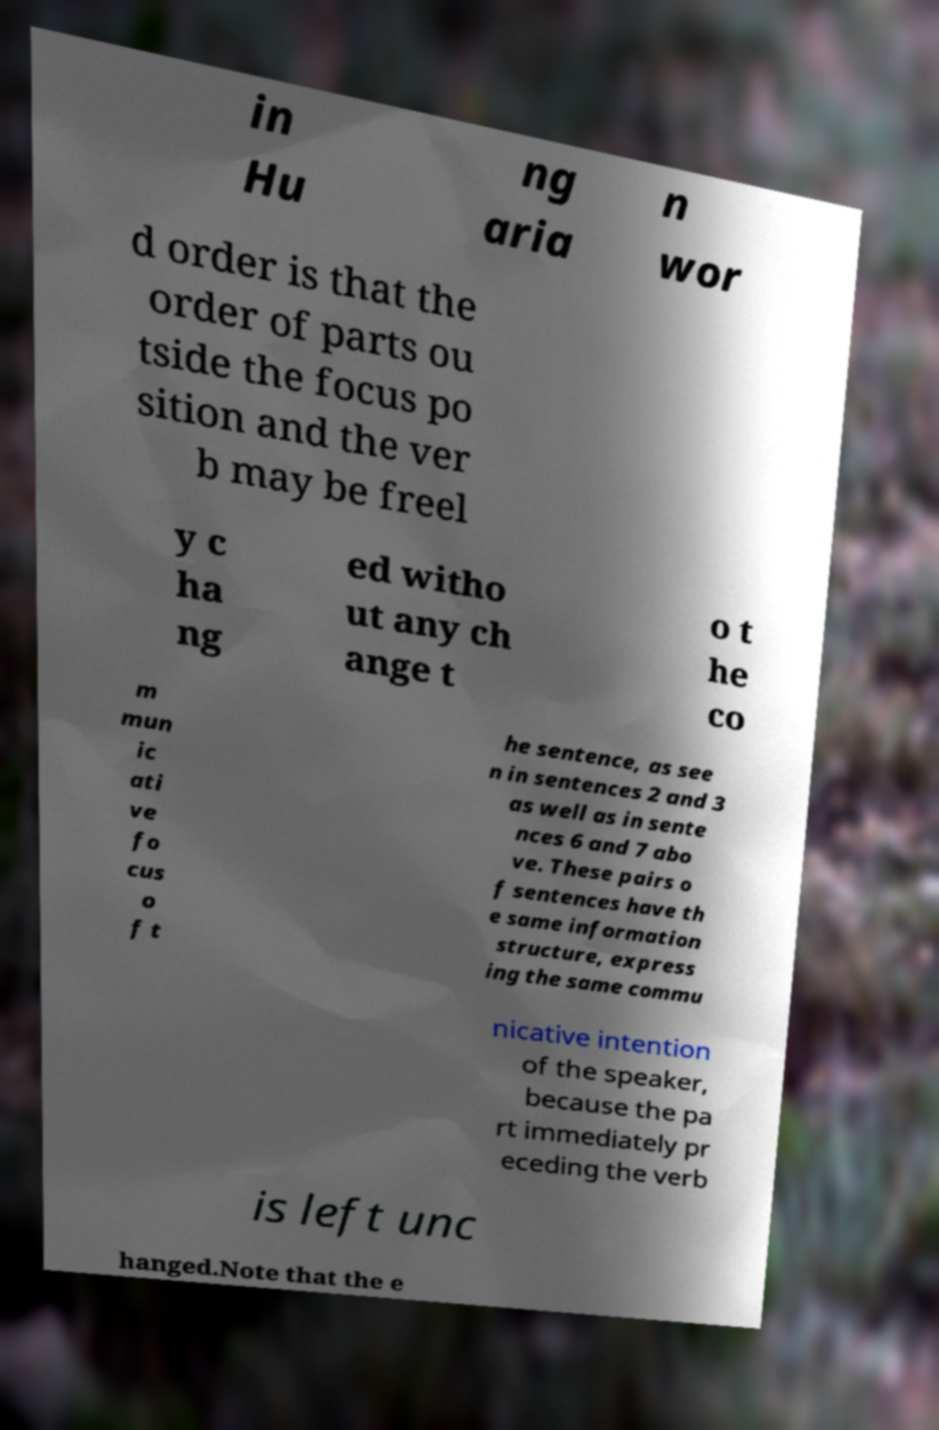There's text embedded in this image that I need extracted. Can you transcribe it verbatim? in Hu ng aria n wor d order is that the order of parts ou tside the focus po sition and the ver b may be freel y c ha ng ed witho ut any ch ange t o t he co m mun ic ati ve fo cus o f t he sentence, as see n in sentences 2 and 3 as well as in sente nces 6 and 7 abo ve. These pairs o f sentences have th e same information structure, express ing the same commu nicative intention of the speaker, because the pa rt immediately pr eceding the verb is left unc hanged.Note that the e 